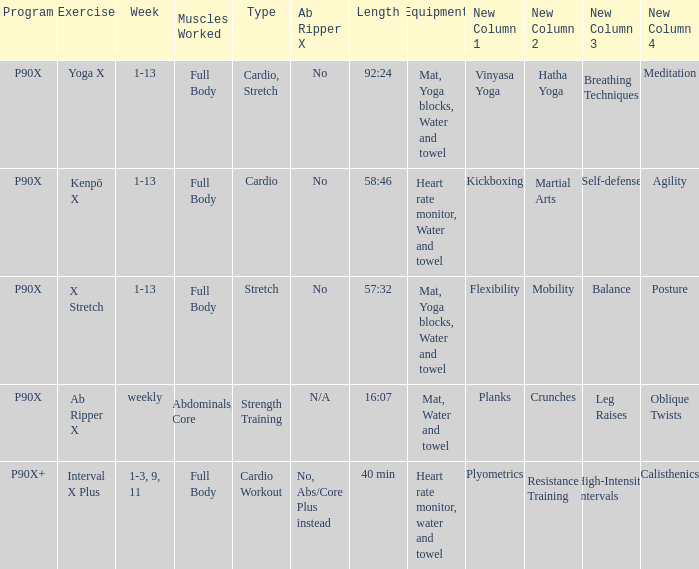What is the week when type is cardio workout? 1-3, 9, 11. 